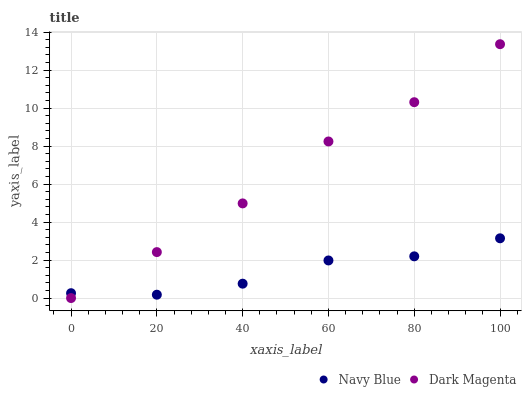Does Navy Blue have the minimum area under the curve?
Answer yes or no. Yes. Does Dark Magenta have the maximum area under the curve?
Answer yes or no. Yes. Does Dark Magenta have the minimum area under the curve?
Answer yes or no. No. Is Dark Magenta the smoothest?
Answer yes or no. Yes. Is Navy Blue the roughest?
Answer yes or no. Yes. Is Dark Magenta the roughest?
Answer yes or no. No. Does Dark Magenta have the lowest value?
Answer yes or no. Yes. Does Dark Magenta have the highest value?
Answer yes or no. Yes. Does Dark Magenta intersect Navy Blue?
Answer yes or no. Yes. Is Dark Magenta less than Navy Blue?
Answer yes or no. No. Is Dark Magenta greater than Navy Blue?
Answer yes or no. No. 